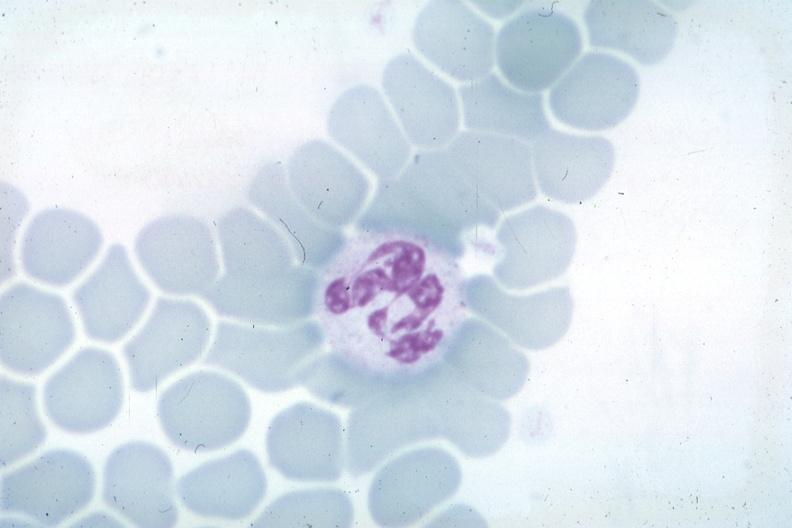how is wrights not the best photograph for color but nuclear change source unknown?
Answer the question using a single word or phrase. Obvious 